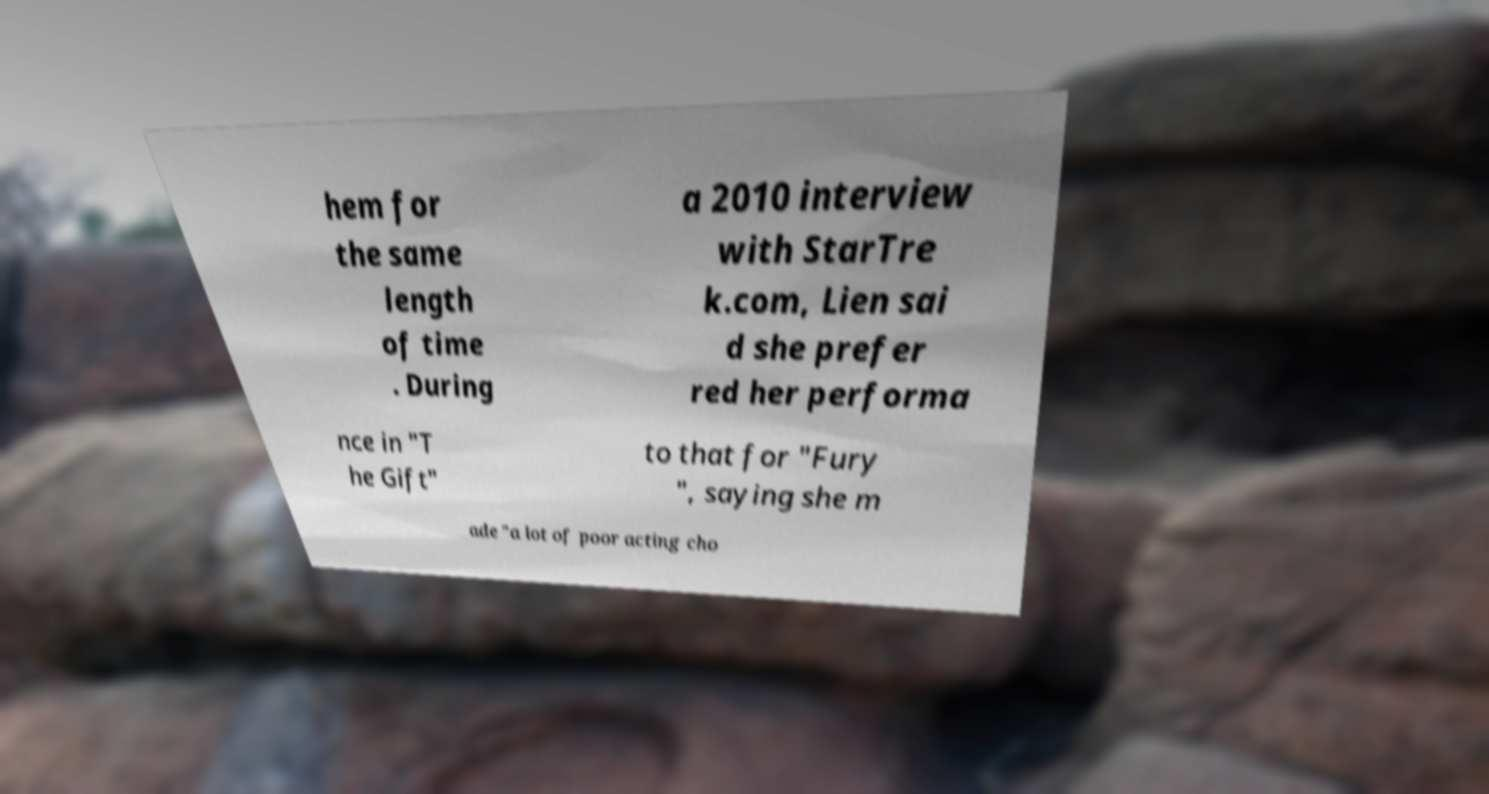Can you read and provide the text displayed in the image?This photo seems to have some interesting text. Can you extract and type it out for me? hem for the same length of time . During a 2010 interview with StarTre k.com, Lien sai d she prefer red her performa nce in "T he Gift" to that for "Fury ", saying she m ade "a lot of poor acting cho 